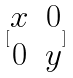Convert formula to latex. <formula><loc_0><loc_0><loc_500><loc_500>[ \begin{matrix} x & 0 \\ 0 & y \\ \end{matrix} ]</formula> 